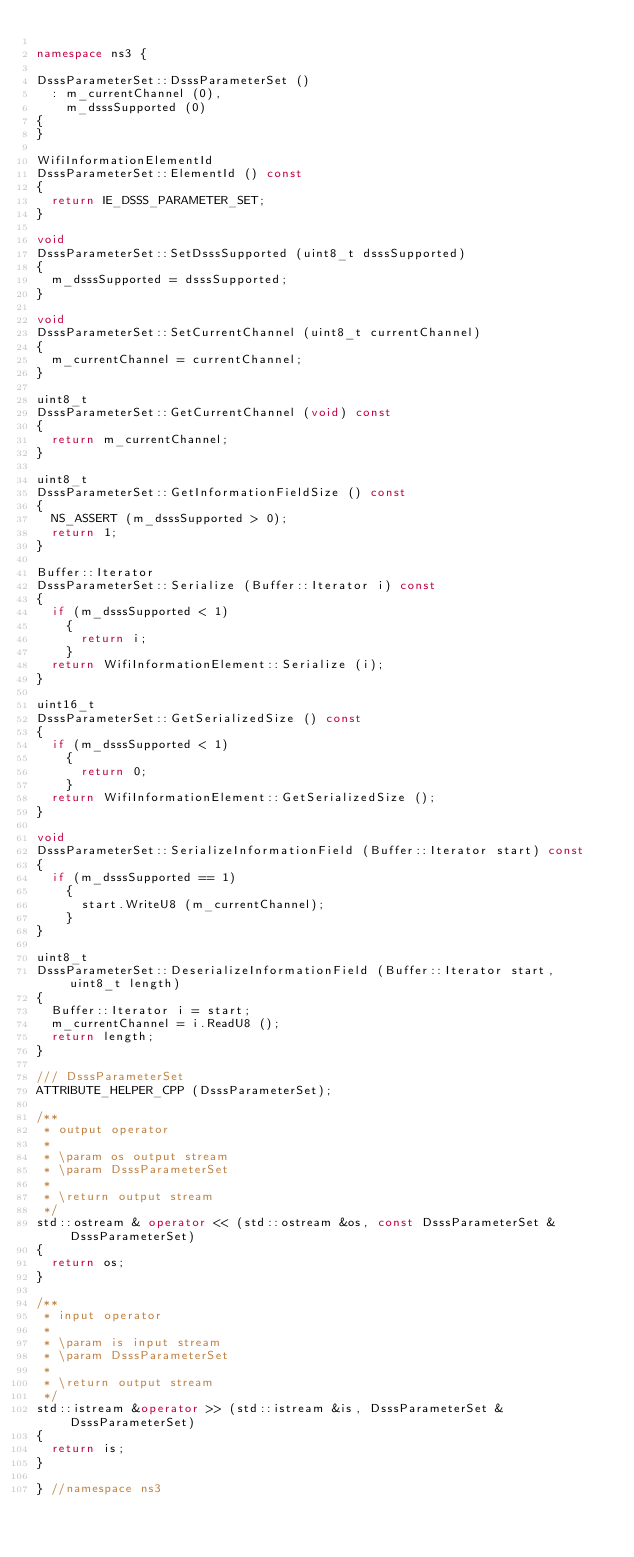Convert code to text. <code><loc_0><loc_0><loc_500><loc_500><_C++_>
namespace ns3 {

DsssParameterSet::DsssParameterSet ()
  : m_currentChannel (0),
    m_dsssSupported (0)
{
}

WifiInformationElementId
DsssParameterSet::ElementId () const
{
  return IE_DSSS_PARAMETER_SET;
}

void
DsssParameterSet::SetDsssSupported (uint8_t dsssSupported)
{
  m_dsssSupported = dsssSupported;
}

void
DsssParameterSet::SetCurrentChannel (uint8_t currentChannel)
{
  m_currentChannel = currentChannel;
}

uint8_t
DsssParameterSet::GetCurrentChannel (void) const
{
  return m_currentChannel;
}

uint8_t
DsssParameterSet::GetInformationFieldSize () const
{
  NS_ASSERT (m_dsssSupported > 0);
  return 1;
}

Buffer::Iterator
DsssParameterSet::Serialize (Buffer::Iterator i) const
{
  if (m_dsssSupported < 1)
    {
      return i;
    }
  return WifiInformationElement::Serialize (i);
}

uint16_t
DsssParameterSet::GetSerializedSize () const
{
  if (m_dsssSupported < 1)
    {
      return 0;
    }
  return WifiInformationElement::GetSerializedSize ();
}

void
DsssParameterSet::SerializeInformationField (Buffer::Iterator start) const
{
  if (m_dsssSupported == 1)
    {
      start.WriteU8 (m_currentChannel);
    }
}

uint8_t
DsssParameterSet::DeserializeInformationField (Buffer::Iterator start, uint8_t length)
{
  Buffer::Iterator i = start;
  m_currentChannel = i.ReadU8 ();
  return length;
}

/// DsssParameterSet
ATTRIBUTE_HELPER_CPP (DsssParameterSet);

/**
 * output operator
 *
 * \param os output stream
 * \param DsssParameterSet
 *
 * \return output stream
 */
std::ostream & operator << (std::ostream &os, const DsssParameterSet &DsssParameterSet)
{
  return os;
}

/**
 * input operator
 *
 * \param is input stream
 * \param DsssParameterSet
 *
 * \return output stream
 */
std::istream &operator >> (std::istream &is, DsssParameterSet &DsssParameterSet)
{
  return is;
}

} //namespace ns3
</code> 